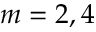<formula> <loc_0><loc_0><loc_500><loc_500>m = 2 , 4</formula> 